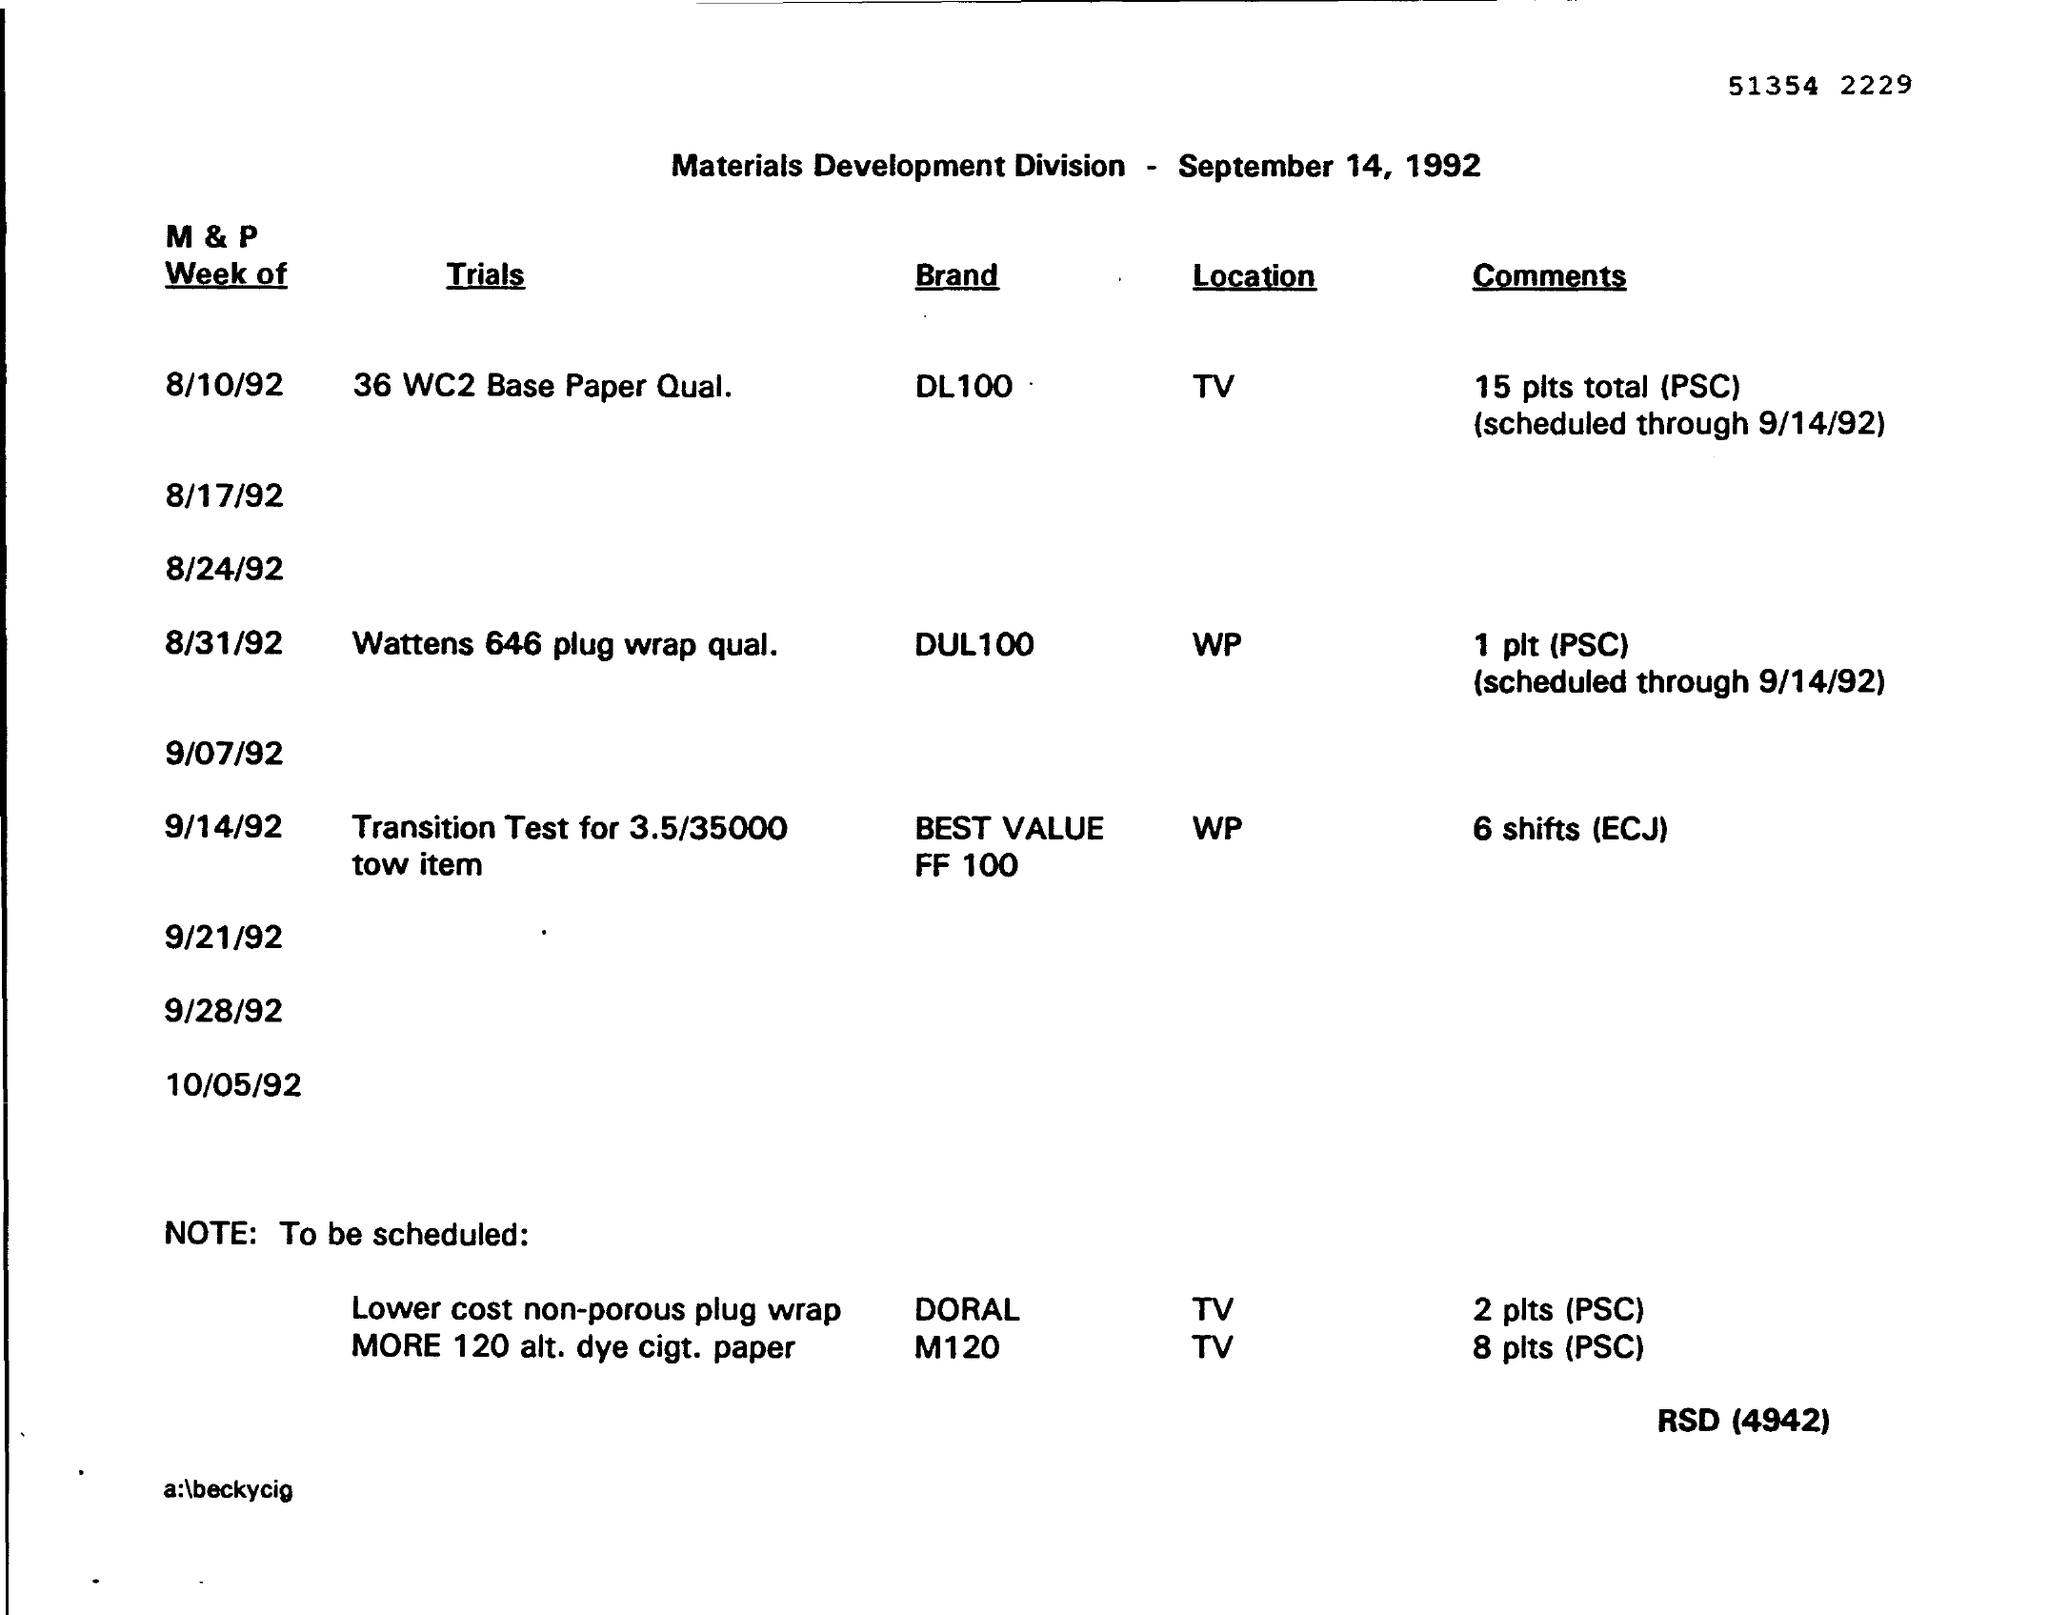Mention a couple of crucial points in this snapshot. The location of the Trial 36 WC2 Base Paper Qual TV is unclear. The location of the Brand DUL 100 is WP... On August 31st, 1992, the Trials' name was Wattens 646 plug wrap qualification. 